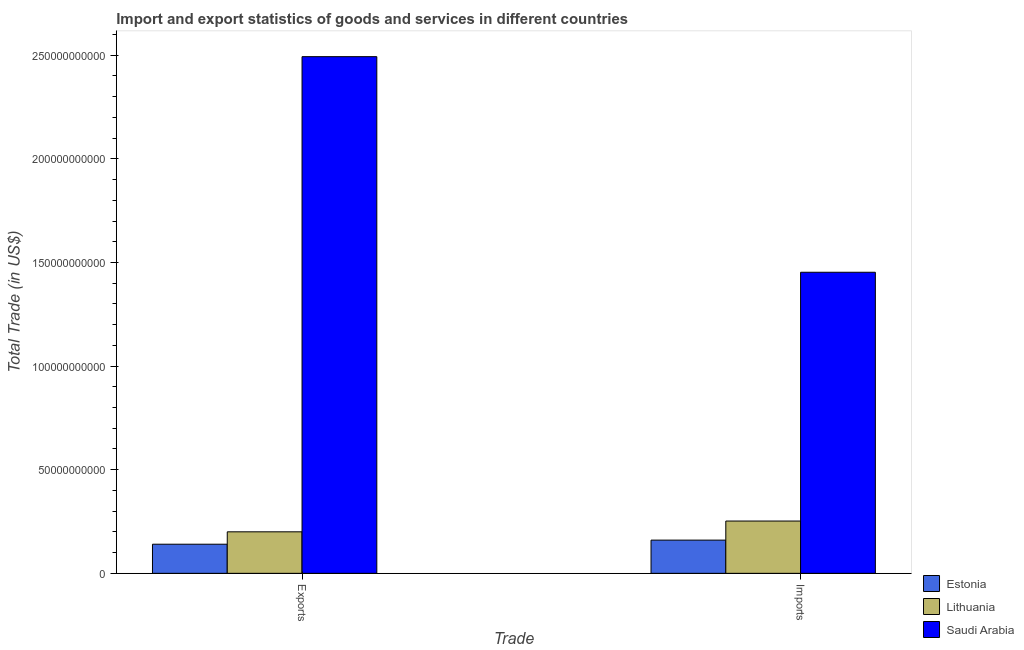Are the number of bars on each tick of the X-axis equal?
Your response must be concise. Yes. How many bars are there on the 2nd tick from the left?
Make the answer very short. 3. What is the label of the 1st group of bars from the left?
Give a very brief answer. Exports. What is the export of goods and services in Saudi Arabia?
Offer a very short reply. 2.49e+11. Across all countries, what is the maximum export of goods and services?
Give a very brief answer. 2.49e+11. Across all countries, what is the minimum imports of goods and services?
Provide a succinct answer. 1.60e+1. In which country was the export of goods and services maximum?
Give a very brief answer. Saudi Arabia. In which country was the imports of goods and services minimum?
Your answer should be compact. Estonia. What is the total imports of goods and services in the graph?
Your answer should be very brief. 1.87e+11. What is the difference between the imports of goods and services in Saudi Arabia and that in Lithuania?
Offer a very short reply. 1.20e+11. What is the difference between the imports of goods and services in Estonia and the export of goods and services in Saudi Arabia?
Ensure brevity in your answer.  -2.33e+11. What is the average export of goods and services per country?
Provide a succinct answer. 9.45e+1. What is the difference between the imports of goods and services and export of goods and services in Saudi Arabia?
Provide a short and direct response. -1.04e+11. What is the ratio of the imports of goods and services in Saudi Arabia to that in Estonia?
Make the answer very short. 9.07. What does the 2nd bar from the left in Imports represents?
Offer a terse response. Lithuania. What does the 2nd bar from the right in Imports represents?
Your answer should be very brief. Lithuania. How many countries are there in the graph?
Your answer should be very brief. 3. Are the values on the major ticks of Y-axis written in scientific E-notation?
Give a very brief answer. No. Where does the legend appear in the graph?
Provide a succinct answer. Bottom right. What is the title of the graph?
Make the answer very short. Import and export statistics of goods and services in different countries. What is the label or title of the X-axis?
Offer a very short reply. Trade. What is the label or title of the Y-axis?
Your answer should be very brief. Total Trade (in US$). What is the Total Trade (in US$) of Estonia in Exports?
Your answer should be compact. 1.41e+1. What is the Total Trade (in US$) of Lithuania in Exports?
Your answer should be very brief. 2.00e+1. What is the Total Trade (in US$) of Saudi Arabia in Exports?
Offer a very short reply. 2.49e+11. What is the Total Trade (in US$) in Estonia in Imports?
Offer a very short reply. 1.60e+1. What is the Total Trade (in US$) of Lithuania in Imports?
Offer a terse response. 2.52e+1. What is the Total Trade (in US$) of Saudi Arabia in Imports?
Offer a very short reply. 1.45e+11. Across all Trade, what is the maximum Total Trade (in US$) of Estonia?
Your response must be concise. 1.60e+1. Across all Trade, what is the maximum Total Trade (in US$) of Lithuania?
Make the answer very short. 2.52e+1. Across all Trade, what is the maximum Total Trade (in US$) of Saudi Arabia?
Ensure brevity in your answer.  2.49e+11. Across all Trade, what is the minimum Total Trade (in US$) in Estonia?
Offer a very short reply. 1.41e+1. Across all Trade, what is the minimum Total Trade (in US$) in Lithuania?
Ensure brevity in your answer.  2.00e+1. Across all Trade, what is the minimum Total Trade (in US$) in Saudi Arabia?
Your answer should be compact. 1.45e+11. What is the total Total Trade (in US$) of Estonia in the graph?
Ensure brevity in your answer.  3.01e+1. What is the total Total Trade (in US$) of Lithuania in the graph?
Provide a short and direct response. 4.53e+1. What is the total Total Trade (in US$) of Saudi Arabia in the graph?
Offer a terse response. 3.95e+11. What is the difference between the Total Trade (in US$) of Estonia in Exports and that in Imports?
Offer a terse response. -1.97e+09. What is the difference between the Total Trade (in US$) in Lithuania in Exports and that in Imports?
Give a very brief answer. -5.20e+09. What is the difference between the Total Trade (in US$) of Saudi Arabia in Exports and that in Imports?
Make the answer very short. 1.04e+11. What is the difference between the Total Trade (in US$) of Estonia in Exports and the Total Trade (in US$) of Lithuania in Imports?
Make the answer very short. -1.12e+1. What is the difference between the Total Trade (in US$) in Estonia in Exports and the Total Trade (in US$) in Saudi Arabia in Imports?
Your answer should be compact. -1.31e+11. What is the difference between the Total Trade (in US$) of Lithuania in Exports and the Total Trade (in US$) of Saudi Arabia in Imports?
Offer a very short reply. -1.25e+11. What is the average Total Trade (in US$) of Estonia per Trade?
Provide a succinct answer. 1.50e+1. What is the average Total Trade (in US$) in Lithuania per Trade?
Offer a very short reply. 2.26e+1. What is the average Total Trade (in US$) in Saudi Arabia per Trade?
Your response must be concise. 1.97e+11. What is the difference between the Total Trade (in US$) in Estonia and Total Trade (in US$) in Lithuania in Exports?
Offer a very short reply. -5.98e+09. What is the difference between the Total Trade (in US$) of Estonia and Total Trade (in US$) of Saudi Arabia in Exports?
Ensure brevity in your answer.  -2.35e+11. What is the difference between the Total Trade (in US$) in Lithuania and Total Trade (in US$) in Saudi Arabia in Exports?
Your response must be concise. -2.29e+11. What is the difference between the Total Trade (in US$) in Estonia and Total Trade (in US$) in Lithuania in Imports?
Your response must be concise. -9.21e+09. What is the difference between the Total Trade (in US$) in Estonia and Total Trade (in US$) in Saudi Arabia in Imports?
Make the answer very short. -1.29e+11. What is the difference between the Total Trade (in US$) of Lithuania and Total Trade (in US$) of Saudi Arabia in Imports?
Provide a succinct answer. -1.20e+11. What is the ratio of the Total Trade (in US$) in Estonia in Exports to that in Imports?
Keep it short and to the point. 0.88. What is the ratio of the Total Trade (in US$) in Lithuania in Exports to that in Imports?
Your response must be concise. 0.79. What is the ratio of the Total Trade (in US$) in Saudi Arabia in Exports to that in Imports?
Give a very brief answer. 1.72. What is the difference between the highest and the second highest Total Trade (in US$) of Estonia?
Your answer should be compact. 1.97e+09. What is the difference between the highest and the second highest Total Trade (in US$) in Lithuania?
Give a very brief answer. 5.20e+09. What is the difference between the highest and the second highest Total Trade (in US$) in Saudi Arabia?
Give a very brief answer. 1.04e+11. What is the difference between the highest and the lowest Total Trade (in US$) in Estonia?
Offer a terse response. 1.97e+09. What is the difference between the highest and the lowest Total Trade (in US$) of Lithuania?
Provide a succinct answer. 5.20e+09. What is the difference between the highest and the lowest Total Trade (in US$) of Saudi Arabia?
Offer a very short reply. 1.04e+11. 